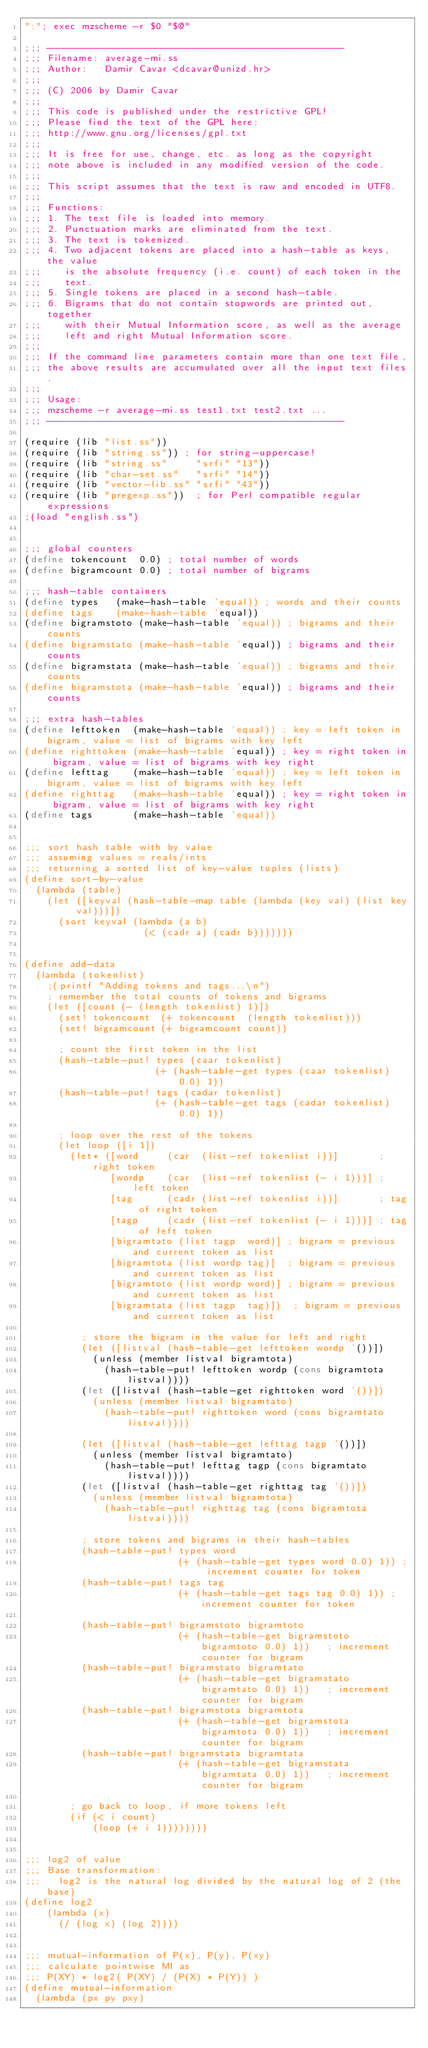Convert code to text. <code><loc_0><loc_0><loc_500><loc_500><_Scheme_>":"; exec mzscheme -r $0 "$@"

;;; ----------------------------------------------------
;;; Filename: average-mi.ss
;;; Author:   Damir Cavar <dcavar@unizd.hr>
;;;
;;; (C) 2006 by Damir Cavar
;;;
;;; This code is published under the restrictive GPL!
;;; Please find the text of the GPL here:
;;; http://www.gnu.org/licenses/gpl.txt
;;; 
;;; It is free for use, change, etc. as long as the copyright
;;; note above is included in any modified version of the code.
;;; 
;;; This script assumes that the text is raw and encoded in UTF8.
;;;
;;; Functions:
;;; 1. The text file is loaded into memory.
;;; 2. Punctuation marks are eliminated from the text.
;;; 3. The text is tokenized.
;;; 4. Two adjacent tokens are placed into a hash-table as keys, the value
;;;    is the absolute frequency (i.e. count) of each token in the
;;;    text.
;;; 5. Single tokens are placed in a second hash-table.
;;; 6. Bigrams that do not contain stopwords are printed out, together
;;;    with their Mutual Information score, as well as the average
;;;    left and right Mutual Information score.
;;;
;;; If the command line parameters contain more than one text file,
;;; the above results are accumulated over all the input text files.
;;;
;;; Usage:
;;; mzscheme -r average-mi.ss test1.txt test2.txt ...
;;; ----------------------------------------------------

(require (lib "list.ss"))
(require (lib "string.ss")) ; for string-uppercase!
(require (lib "string.ss"     "srfi" "13"))
(require (lib "char-set.ss"   "srfi" "14"))
(require (lib "vector-lib.ss" "srfi" "43"))
(require (lib "pregexp.ss"))  ; for Perl compatible regular expressions
;(load "english.ss")


;;; global counters
(define tokencount  0.0) ; total number of words
(define bigramcount 0.0) ; total number of bigrams

;;; hash-table containers
(define types   (make-hash-table 'equal)) ; words and their counts
(define tags    (make-hash-table 'equal))
(define bigramstoto (make-hash-table 'equal)) ; bigrams and their counts
(define bigramstato (make-hash-table 'equal)) ; bigrams and their counts
(define bigramstata (make-hash-table 'equal)) ; bigrams and their counts
(define bigramstota (make-hash-table 'equal)) ; bigrams and their counts

;;; extra hash-tables
(define lefttoken  (make-hash-table 'equal)) ; key = left token in bigram, value = list of bigrams with key left
(define righttoken (make-hash-table 'equal)) ; key = right token in bigram, value = list of bigrams with key right
(define lefttag    (make-hash-table 'equal)) ; key = left token in bigram, value = list of bigrams with key left
(define righttag   (make-hash-table 'equal)) ; key = right token in bigram, value = list of bigrams with key right
(define tags       (make-hash-table 'equal))


;;; sort hash table with by value
;;; assuming values = reals/ints
;;; returning a sorted list of key-value tuples (lists)
(define sort-by-value
  (lambda (table)
    (let ([keyval (hash-table-map table (lambda (key val) (list key val)))])
      (sort keyval (lambda (a b)
                     (< (cadr a) (cadr b)))))))


(define add-data
  (lambda (tokenlist)
    ;(printf "Adding tokens and tags...\n")
    ; remember the total counts of tokens and bigrams
    (let ([count (- (length tokenlist) 1)])
      (set! tokencount  (+ tokencount  (length tokenlist)))
      (set! bigramcount (+ bigramcount count))

      ; count the first token in the list
      (hash-table-put! types (caar tokenlist)
                       (+ (hash-table-get types (caar tokenlist) 0.0) 1))
      (hash-table-put! tags (cadar tokenlist)
                       (+ (hash-table-get tags (cadar tokenlist) 0.0) 1))

      ; loop over the rest of the tokens
      (let loop ([i 1])
        (let* ([word     (car  (list-ref tokenlist i))]       ; right token
               [wordp    (car  (list-ref tokenlist (- i 1)))] ; left token
               [tag      (cadr (list-ref tokenlist i))]       ; tag of right token
               [tagp     (cadr (list-ref tokenlist (- i 1)))] ; tag of left token
               [bigramtato (list tagp  word)] ; bigram = previous and current token as list
               [bigramtota (list wordp tag)]  ; bigram = previous and current token as list
               [bigramtoto (list wordp word)] ; bigram = previous and current token as list
               [bigramtata (list tagp  tag)])  ; bigram = previous and current token as list

          ; store the bigram in the value for left and right
          (let ([listval (hash-table-get lefttoken wordp '())])
            (unless (member listval bigramtota)
              (hash-table-put! lefttoken wordp (cons bigramtota listval))))
          (let ([listval (hash-table-get righttoken word '())])
            (unless (member listval bigramtato)
              (hash-table-put! righttoken word (cons bigramtato listval))))
          
          (let ([listval (hash-table-get lefttag tagp '())])
            (unless (member listval bigramtato)
              (hash-table-put! lefttag tagp (cons bigramtato listval))))
          (let ([listval (hash-table-get righttag tag '())])
            (unless (member listval bigramtota)
              (hash-table-put! righttag tag (cons bigramtota listval))))

          ; store tokens and bigrams in their hash-tables
          (hash-table-put! types word
                           (+ (hash-table-get types word 0.0) 1)) ; increment counter for token
          (hash-table-put! tags tag
                           (+ (hash-table-get tags tag 0.0) 1)) ; increment counter for token
          
          (hash-table-put! bigramstoto bigramtoto
                           (+ (hash-table-get bigramstoto bigramtoto 0.0) 1))   ; increment counter for bigram
          (hash-table-put! bigramstato bigramtato
                           (+ (hash-table-get bigramstato bigramtato 0.0) 1))   ; increment counter for bigram
          (hash-table-put! bigramstota bigramtota
                           (+ (hash-table-get bigramstota bigramtota 0.0) 1))   ; increment counter for bigram
          (hash-table-put! bigramstata bigramtata
                           (+ (hash-table-get bigramstata bigramtata 0.0) 1))   ; increment counter for bigram

        ; go back to loop, if more tokens left
        (if (< i count)
            (loop (+ i 1))))))))


;;; log2 of value
;;; Base transformation:
;;;   log2 is the natural log divided by the natural log of 2 (the base)
(define log2
    (lambda (x)
      (/ (log x) (log 2))))


;;; mutual-information of P(x), P(y), P(xy)
;;; calculate pointwise MI as
;;; P(XY) * log2( P(XY) / (P(X) * P(Y)) )
(define mutual-information
  (lambda (px py pxy)</code> 